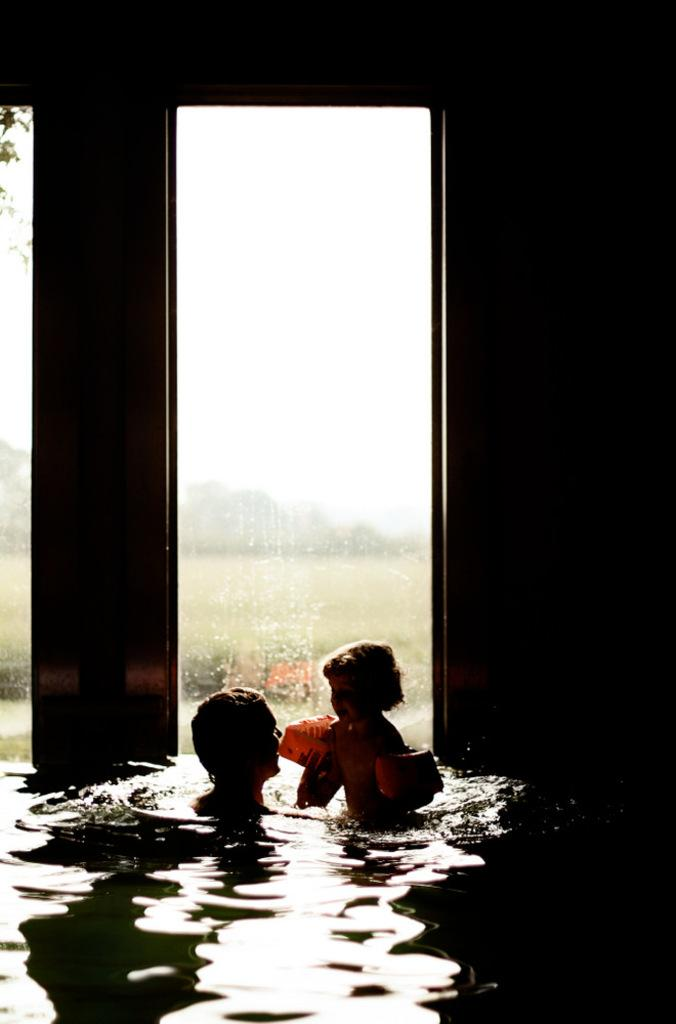What are the people in the image doing? There are people swimming in the water. What is the purpose of the glass window in the image? The glass window is not the main focus of the image, but it is present. How would you describe the background of the image? The background of the image is blurred. What color scheme is used in the image? The image is in black and white color. How many bikes are parked near the people swimming in the image? There are no bikes present in the image. What type of curve can be seen in the water where the people are swimming? There is no curve visible in the water where the people are swimming; the water appears to be flat. 